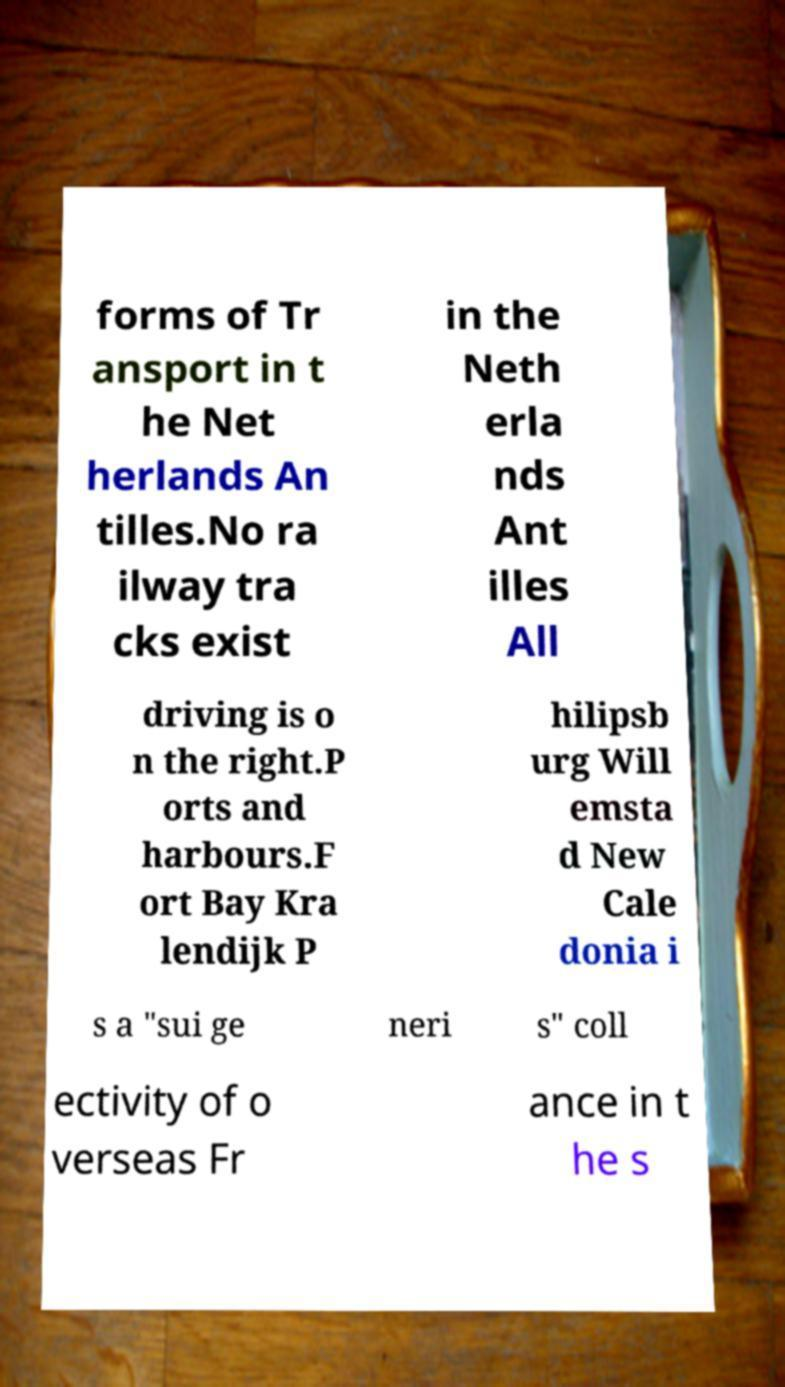What messages or text are displayed in this image? I need them in a readable, typed format. forms of Tr ansport in t he Net herlands An tilles.No ra ilway tra cks exist in the Neth erla nds Ant illes All driving is o n the right.P orts and harbours.F ort Bay Kra lendijk P hilipsb urg Will emsta d New Cale donia i s a "sui ge neri s" coll ectivity of o verseas Fr ance in t he s 